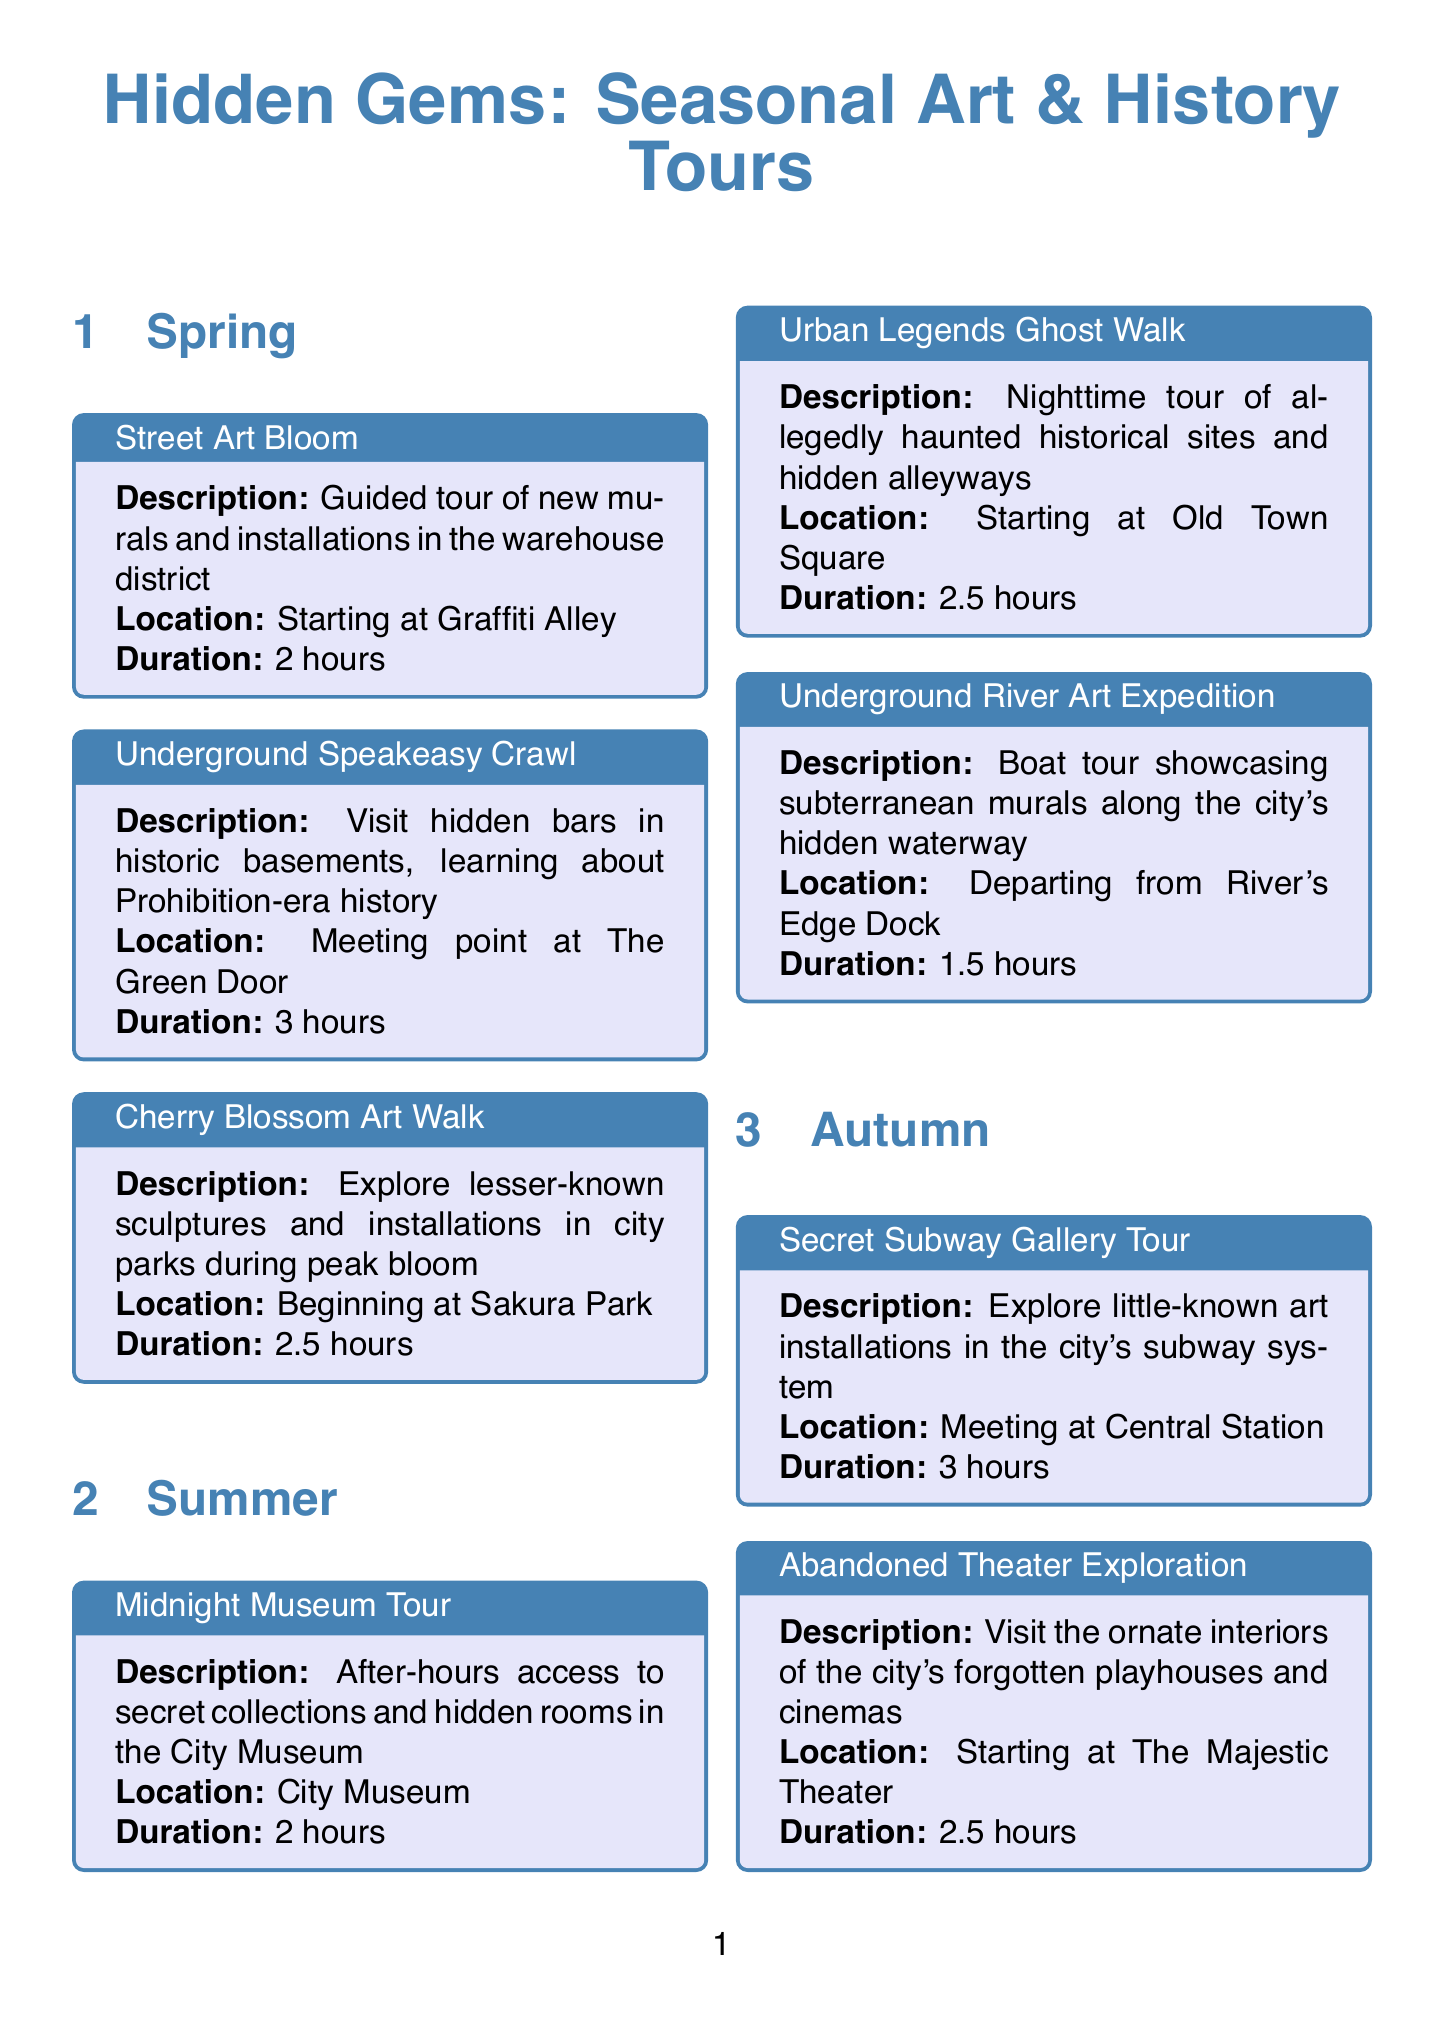what is the duration of the "Underground River Art Expedition"? The duration is listed in the event details for "Underground River Art Expedition," which states it lasts for 1.5 hours.
Answer: 1.5 hours where does the "Cherry Blossom Art Walk" start? The location for the "Cherry Blossom Art Walk" is specified as "Beginning at Sakura Park."
Answer: Beginning at Sakura Park when does the "Hidden History Open Days" occur? The date for "Hidden History Open Days" is provided clearly in the document, stating it takes place on the last weekend of May.
Answer: Last weekend of May who specializes in street art and urban legends? The document lists tour guides with their specialties, indicating Sofia Martinez specializes in street art and urban legends.
Answer: Sofia Martinez how long is the "Catacombs by Candlelight" tour? The duration for the "Catacombs by Candlelight" tour is mentioned as 1.5 hours in the event description.
Answer: 1.5 hours how many events are there in Spring? By counting the events listed under the Spring section, there are three distinct events described.
Answer: 3 what special event happens during the first week of October? The document specifies that the "Annual Underground Arts Festival" takes place during the first week of October.
Answer: Annual Underground Arts Festival which guide speaks Japanese? The document indicates that Yuki Tanaka is the guide who speaks Japanese among the listed tour guides.
Answer: Yuki Tanaka 